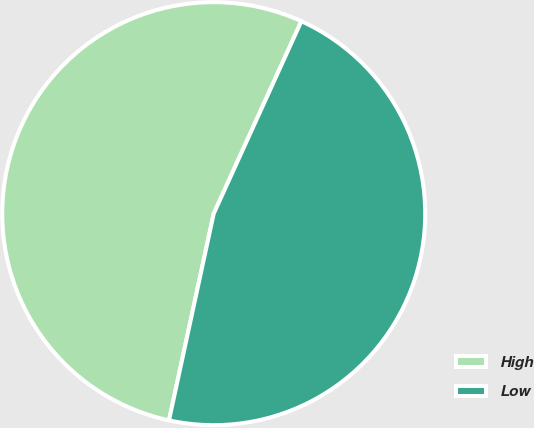Convert chart. <chart><loc_0><loc_0><loc_500><loc_500><pie_chart><fcel>High<fcel>Low<nl><fcel>53.41%<fcel>46.59%<nl></chart> 